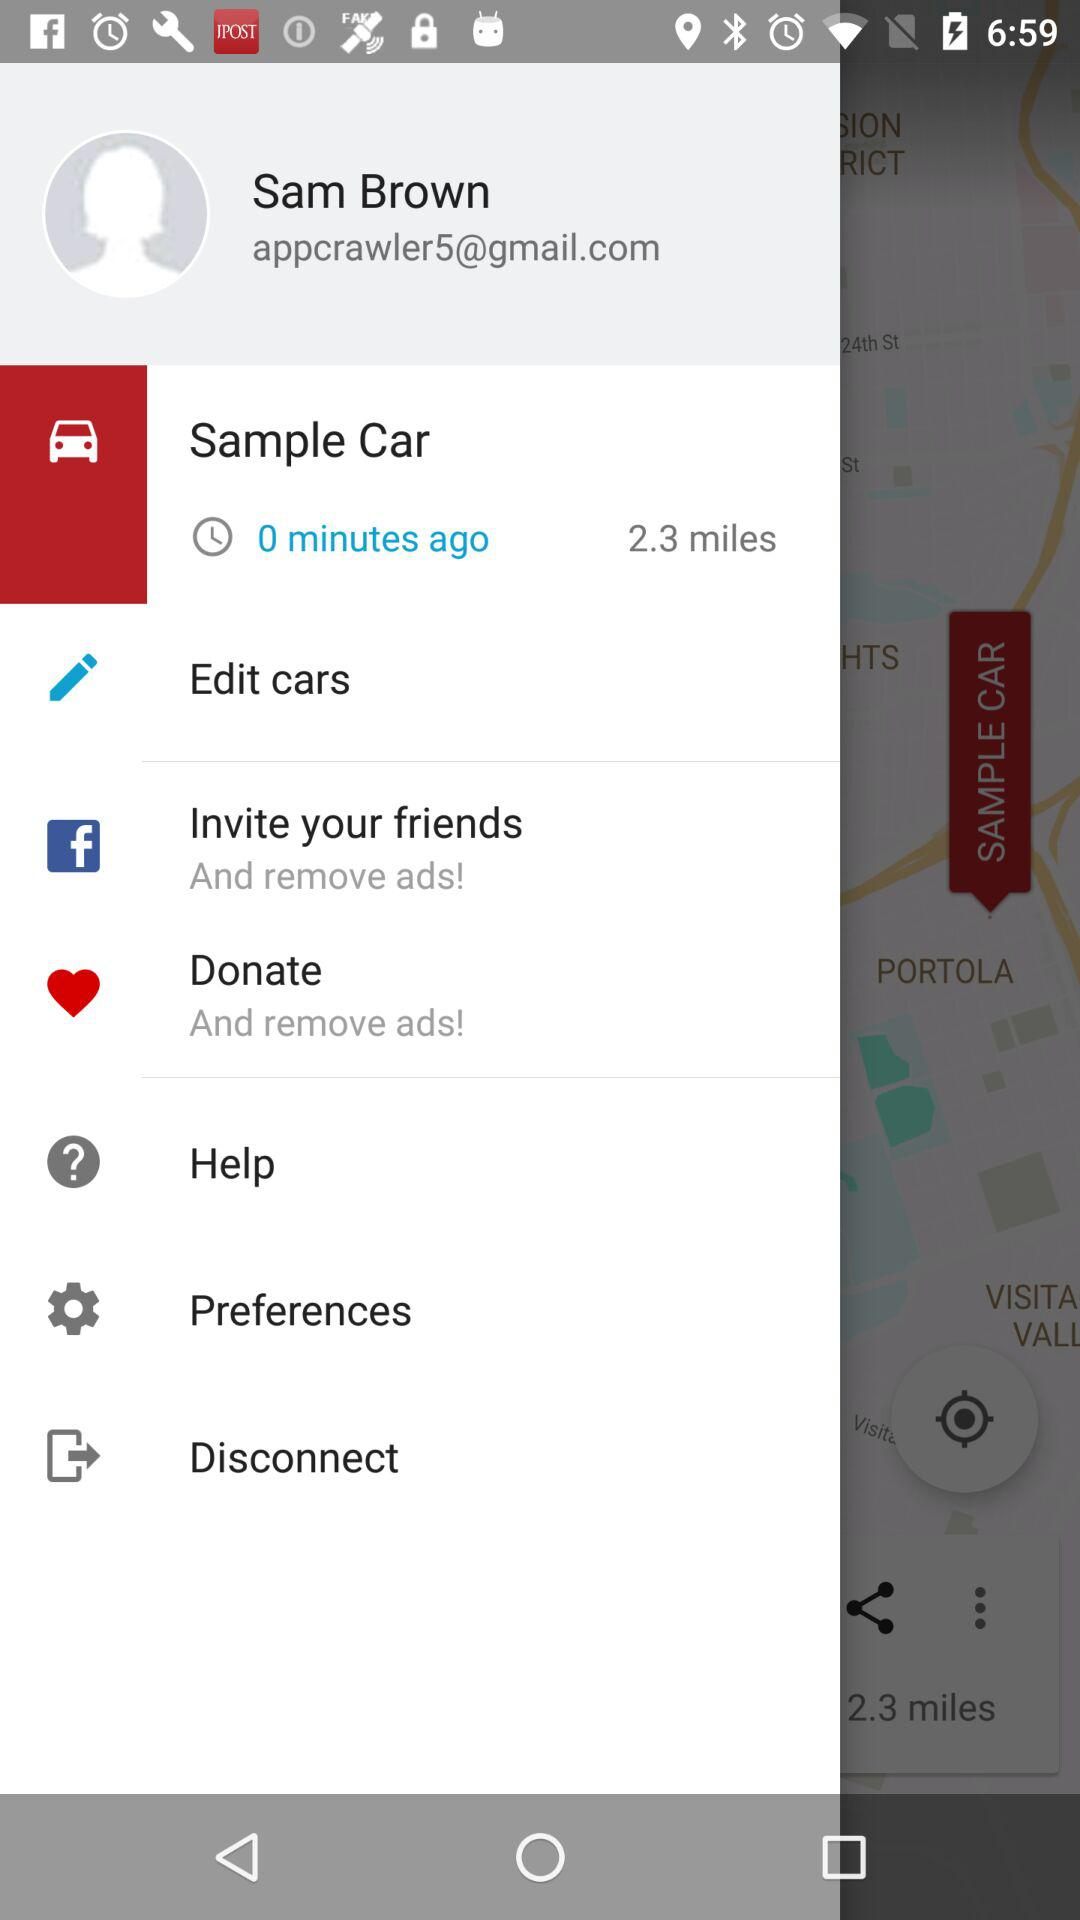What is the name of the user? The name of the user is "Sam Brown". 